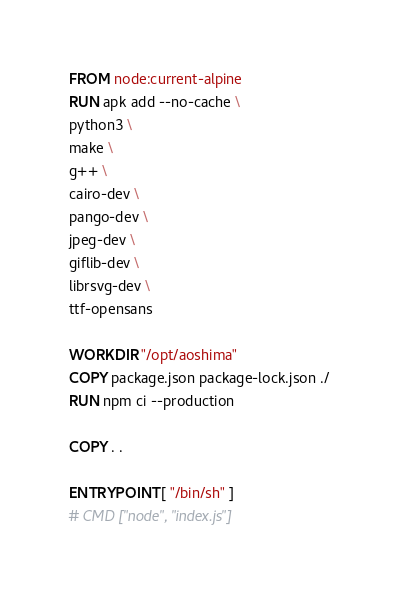<code> <loc_0><loc_0><loc_500><loc_500><_Dockerfile_>FROM node:current-alpine
RUN apk add --no-cache \
python3 \
make \
g++ \
cairo-dev \
pango-dev \
jpeg-dev \
giflib-dev \
librsvg-dev \
ttf-opensans

WORKDIR "/opt/aoshima"
COPY package.json package-lock.json ./
RUN npm ci --production

COPY . .

ENTRYPOINT [ "/bin/sh" ]
# CMD ["node", "index.js"]</code> 